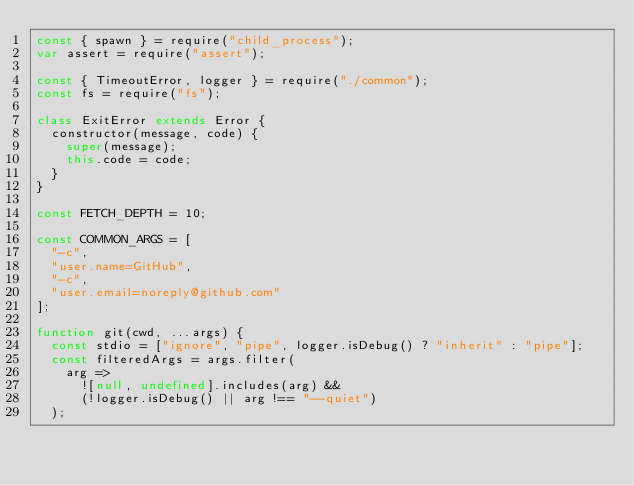Convert code to text. <code><loc_0><loc_0><loc_500><loc_500><_JavaScript_>const { spawn } = require("child_process");
var assert = require("assert");

const { TimeoutError, logger } = require("./common");
const fs = require("fs");

class ExitError extends Error {
  constructor(message, code) {
    super(message);
    this.code = code;
  }
}

const FETCH_DEPTH = 10;

const COMMON_ARGS = [
  "-c",
  "user.name=GitHub",
  "-c",
  "user.email=noreply@github.com"
];

function git(cwd, ...args) {
  const stdio = ["ignore", "pipe", logger.isDebug() ? "inherit" : "pipe"];
  const filteredArgs = args.filter(
    arg =>
      ![null, undefined].includes(arg) &&
      (!logger.isDebug() || arg !== "--quiet")
  );</code> 